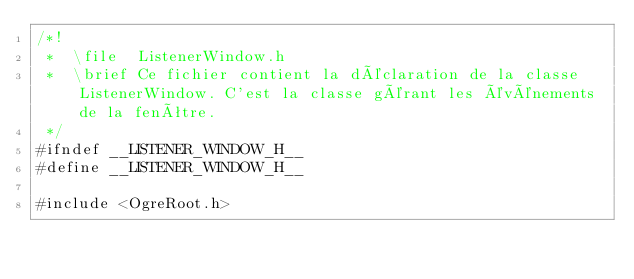<code> <loc_0><loc_0><loc_500><loc_500><_C_>/*!
 *  \file  ListenerWindow.h
 *  \brief Ce fichier contient la déclaration de la classe ListenerWindow. C'est la classe gérant les événements de la fenêtre.
 */
#ifndef __LISTENER_WINDOW_H__
#define __LISTENER_WINDOW_H__

#include <OgreRoot.h></code> 